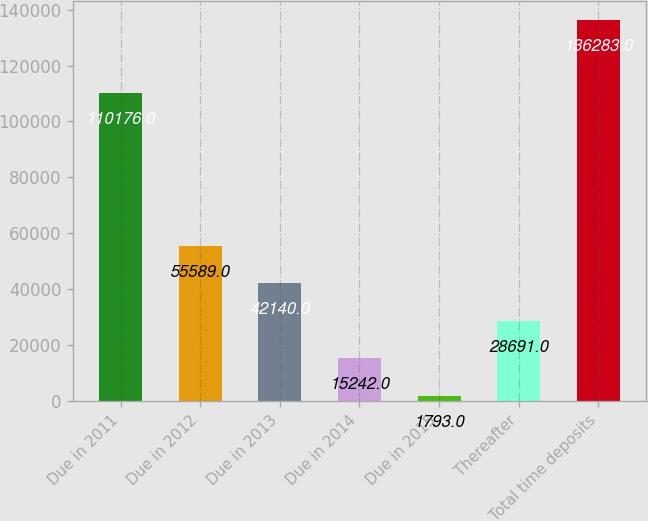Convert chart to OTSL. <chart><loc_0><loc_0><loc_500><loc_500><bar_chart><fcel>Due in 2011<fcel>Due in 2012<fcel>Due in 2013<fcel>Due in 2014<fcel>Due in 2015<fcel>Thereafter<fcel>Total time deposits<nl><fcel>110176<fcel>55589<fcel>42140<fcel>15242<fcel>1793<fcel>28691<fcel>136283<nl></chart> 